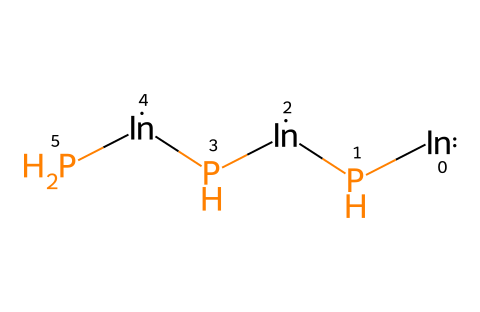What is the primary composition of this quantum dot? The SMILES representation shows indium and phosphorus atoms are combined, indicating that the primary composition is indium phosphide.
Answer: indium phosphide How many indium atoms are present in the structure? In the SMILES, each "[In]" represents a single indium atom. Looking at the structure, there are three "[In]" which means there are three indium atoms.
Answer: 3 What type of crystal lattice arrangement is suggested by this composition? Indium phosphide typically forms a zinc blende structure, which is common for binary semiconductors. The repeating units in the structure align with this arrangement.
Answer: zinc blende How many phosphorus atoms are present in this quantum dot? Each "[P]" in the SMILES represents a phosphorus atom. The structure has three "[P]" atoms, indicating that there are three phosphorus atoms in total.
Answer: 3 What does the presence of both indium and phosphorus in this quantum dot indicate about its conductivity? The combination of indium and phosphorus suggests the material may exhibit semiconductor properties, common in indium phosphide quantum dots. This is due to the charge carrier dynamics found in such semiconductor materials.
Answer: semiconductor What type of properties would you expect from indium phosphide quantum dots? Given that indium phosphide is a semiconductor, one would expect properties such as photoluminescence, electron mobility, and tunability in optical properties, which are typical of quantum dot materials.
Answer: photoluminescence 